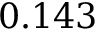<formula> <loc_0><loc_0><loc_500><loc_500>0 . 1 4 3</formula> 